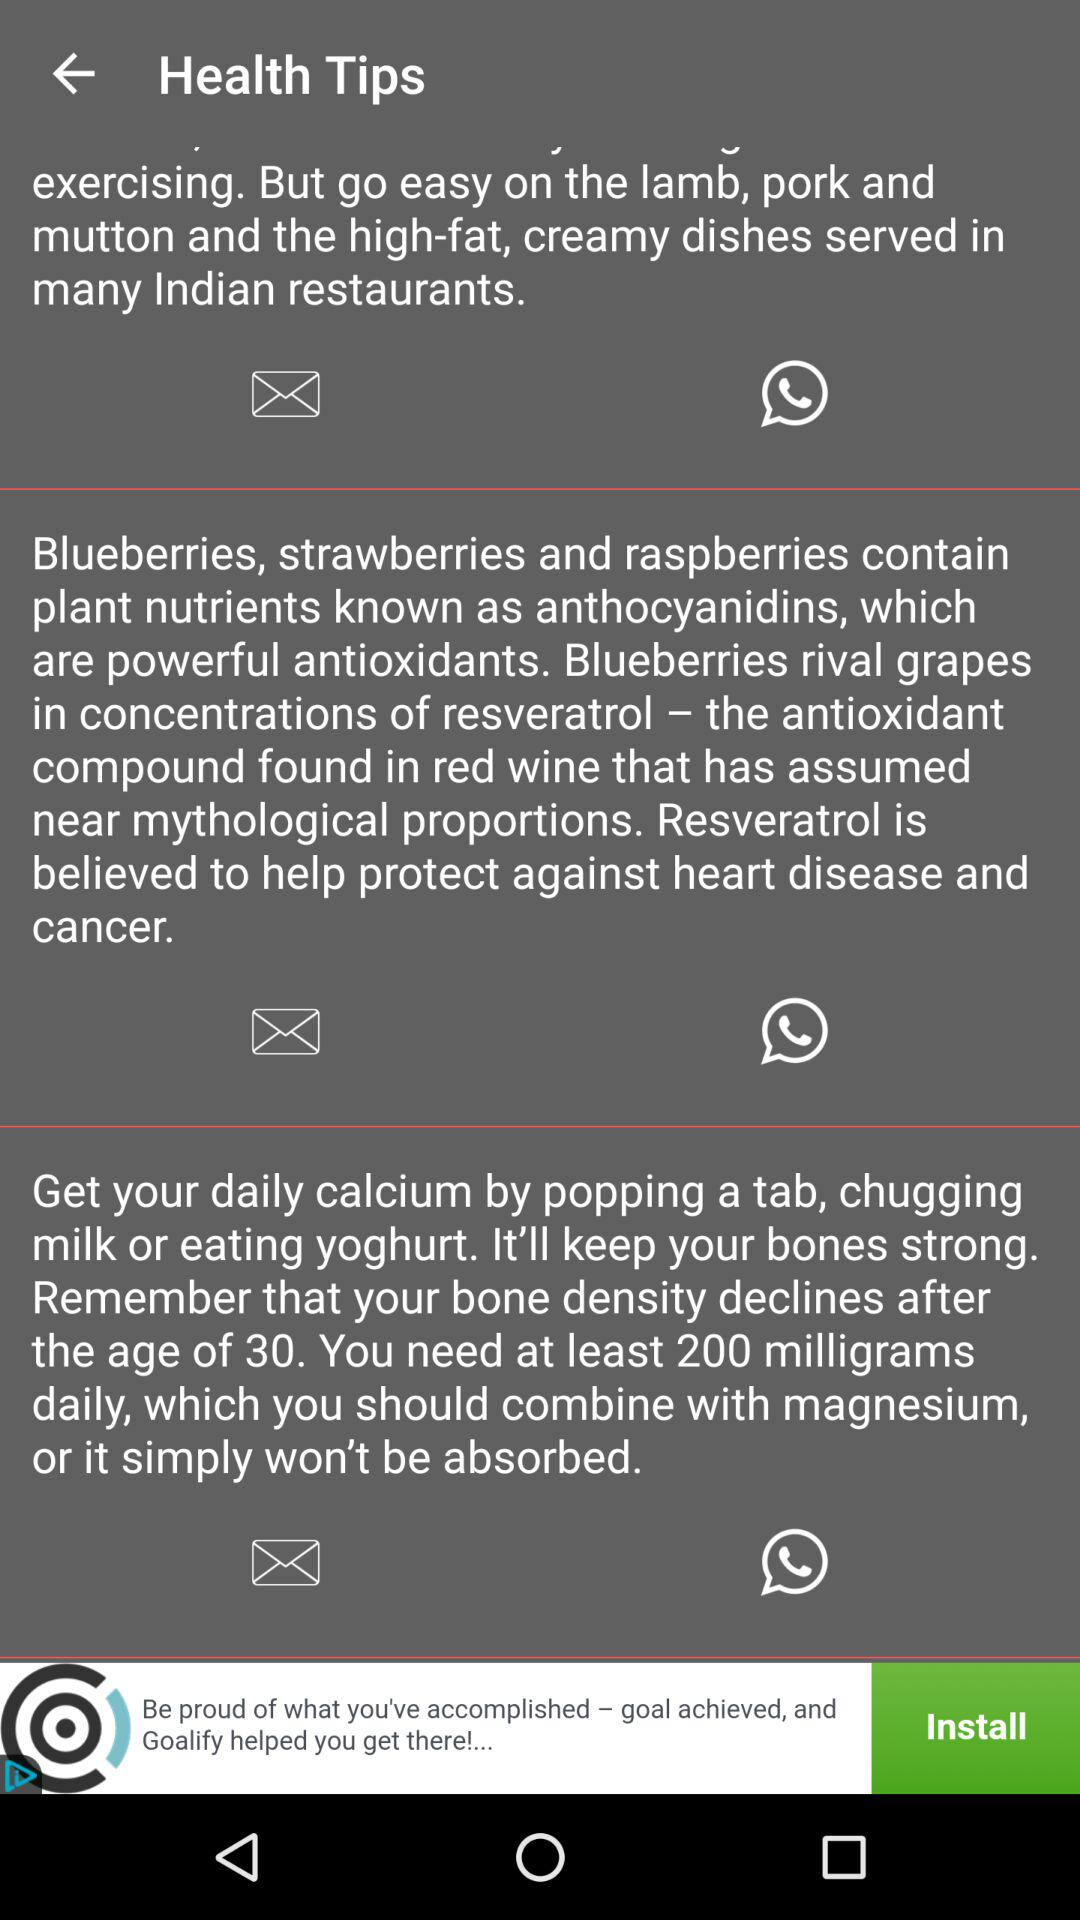Which dishes are served in Indian restaurants? In Indian restaurants, high-fat and creamy dishes are served. 